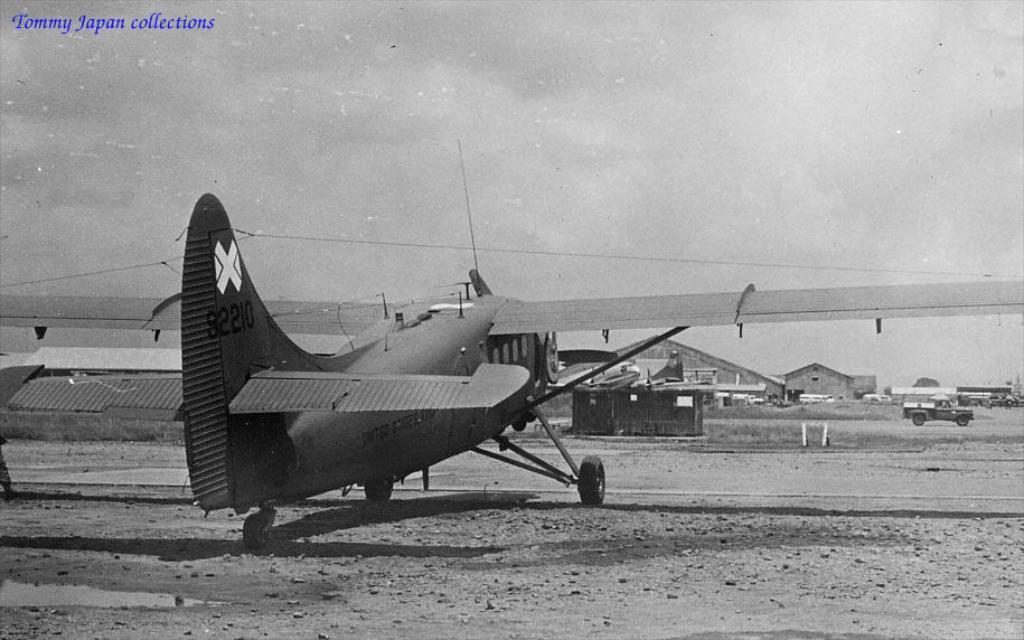Could you give a brief overview of what you see in this image? In the given image i can see a helicopter and some other vehicles. 